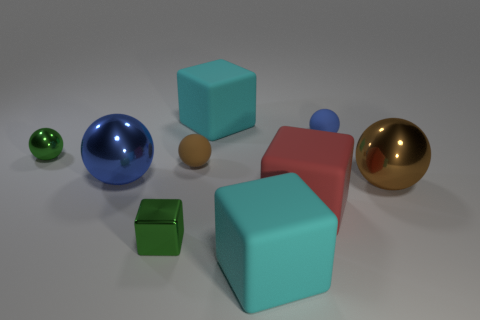Subtract 1 blocks. How many blocks are left? 3 Subtract all tiny green balls. How many balls are left? 4 Subtract all green spheres. How many spheres are left? 4 Subtract all cyan spheres. Subtract all brown cubes. How many spheres are left? 5 Add 1 large yellow cylinders. How many objects exist? 10 Subtract all spheres. How many objects are left? 4 Subtract all large cyan spheres. Subtract all blue matte balls. How many objects are left? 8 Add 2 tiny brown matte objects. How many tiny brown matte objects are left? 3 Add 5 balls. How many balls exist? 10 Subtract 0 red spheres. How many objects are left? 9 